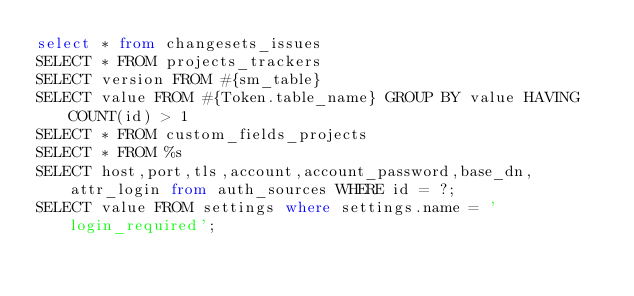<code> <loc_0><loc_0><loc_500><loc_500><_SQL_>select * from changesets_issues
SELECT * FROM projects_trackers
SELECT version FROM #{sm_table}
SELECT value FROM #{Token.table_name} GROUP BY value HAVING COUNT(id) > 1
SELECT * FROM custom_fields_projects
SELECT * FROM %s
SELECT host,port,tls,account,account_password,base_dn,attr_login from auth_sources WHERE id = ?;
SELECT value FROM settings where settings.name = 'login_required';
</code> 